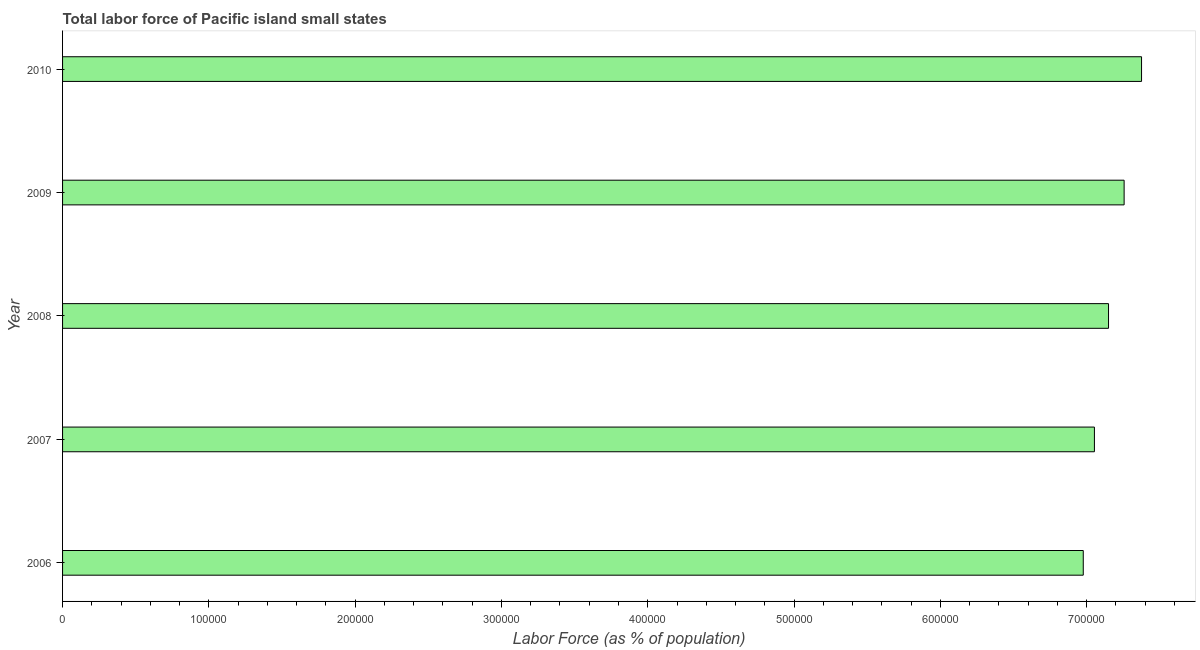Does the graph contain any zero values?
Your answer should be compact. No. What is the title of the graph?
Provide a succinct answer. Total labor force of Pacific island small states. What is the label or title of the X-axis?
Provide a short and direct response. Labor Force (as % of population). What is the label or title of the Y-axis?
Ensure brevity in your answer.  Year. What is the total labor force in 2009?
Your answer should be compact. 7.26e+05. Across all years, what is the maximum total labor force?
Offer a terse response. 7.38e+05. Across all years, what is the minimum total labor force?
Ensure brevity in your answer.  6.98e+05. In which year was the total labor force maximum?
Offer a very short reply. 2010. What is the sum of the total labor force?
Give a very brief answer. 3.58e+06. What is the difference between the total labor force in 2006 and 2010?
Your answer should be very brief. -3.98e+04. What is the average total labor force per year?
Your answer should be compact. 7.16e+05. What is the median total labor force?
Provide a succinct answer. 7.15e+05. In how many years, is the total labor force greater than 600000 %?
Make the answer very short. 5. What is the ratio of the total labor force in 2006 to that in 2010?
Give a very brief answer. 0.95. Is the difference between the total labor force in 2008 and 2010 greater than the difference between any two years?
Give a very brief answer. No. What is the difference between the highest and the second highest total labor force?
Your response must be concise. 1.19e+04. Is the sum of the total labor force in 2006 and 2010 greater than the maximum total labor force across all years?
Give a very brief answer. Yes. What is the difference between the highest and the lowest total labor force?
Give a very brief answer. 3.98e+04. How many bars are there?
Offer a terse response. 5. Are all the bars in the graph horizontal?
Offer a very short reply. Yes. What is the difference between two consecutive major ticks on the X-axis?
Give a very brief answer. 1.00e+05. Are the values on the major ticks of X-axis written in scientific E-notation?
Give a very brief answer. No. What is the Labor Force (as % of population) in 2006?
Your answer should be compact. 6.98e+05. What is the Labor Force (as % of population) in 2007?
Ensure brevity in your answer.  7.05e+05. What is the Labor Force (as % of population) in 2008?
Provide a short and direct response. 7.15e+05. What is the Labor Force (as % of population) of 2009?
Your response must be concise. 7.26e+05. What is the Labor Force (as % of population) of 2010?
Ensure brevity in your answer.  7.38e+05. What is the difference between the Labor Force (as % of population) in 2006 and 2007?
Keep it short and to the point. -7623. What is the difference between the Labor Force (as % of population) in 2006 and 2008?
Give a very brief answer. -1.73e+04. What is the difference between the Labor Force (as % of population) in 2006 and 2009?
Ensure brevity in your answer.  -2.79e+04. What is the difference between the Labor Force (as % of population) in 2006 and 2010?
Ensure brevity in your answer.  -3.98e+04. What is the difference between the Labor Force (as % of population) in 2007 and 2008?
Provide a short and direct response. -9641. What is the difference between the Labor Force (as % of population) in 2007 and 2009?
Ensure brevity in your answer.  -2.03e+04. What is the difference between the Labor Force (as % of population) in 2007 and 2010?
Your answer should be very brief. -3.22e+04. What is the difference between the Labor Force (as % of population) in 2008 and 2009?
Ensure brevity in your answer.  -1.07e+04. What is the difference between the Labor Force (as % of population) in 2008 and 2010?
Your answer should be very brief. -2.26e+04. What is the difference between the Labor Force (as % of population) in 2009 and 2010?
Ensure brevity in your answer.  -1.19e+04. What is the ratio of the Labor Force (as % of population) in 2006 to that in 2007?
Provide a short and direct response. 0.99. What is the ratio of the Labor Force (as % of population) in 2006 to that in 2008?
Offer a very short reply. 0.98. What is the ratio of the Labor Force (as % of population) in 2006 to that in 2009?
Your answer should be compact. 0.96. What is the ratio of the Labor Force (as % of population) in 2006 to that in 2010?
Keep it short and to the point. 0.95. What is the ratio of the Labor Force (as % of population) in 2007 to that in 2008?
Offer a very short reply. 0.99. What is the ratio of the Labor Force (as % of population) in 2007 to that in 2010?
Your answer should be compact. 0.96. What is the ratio of the Labor Force (as % of population) in 2009 to that in 2010?
Provide a short and direct response. 0.98. 